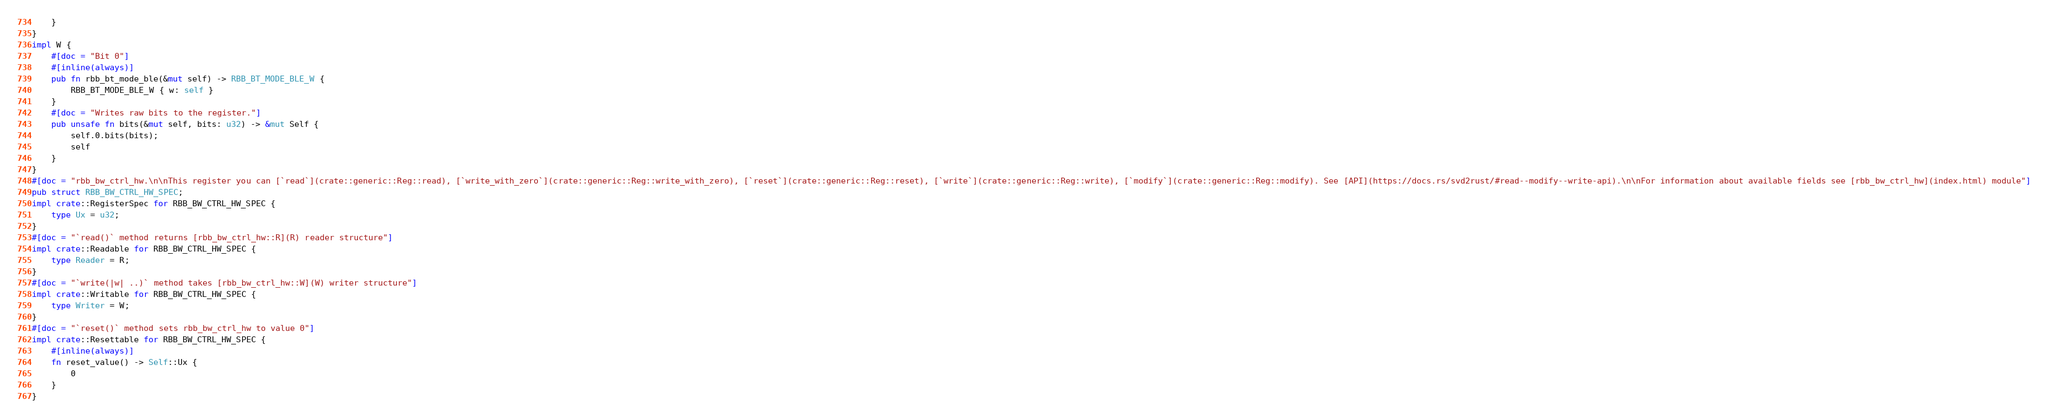<code> <loc_0><loc_0><loc_500><loc_500><_Rust_>    }
}
impl W {
    #[doc = "Bit 0"]
    #[inline(always)]
    pub fn rbb_bt_mode_ble(&mut self) -> RBB_BT_MODE_BLE_W {
        RBB_BT_MODE_BLE_W { w: self }
    }
    #[doc = "Writes raw bits to the register."]
    pub unsafe fn bits(&mut self, bits: u32) -> &mut Self {
        self.0.bits(bits);
        self
    }
}
#[doc = "rbb_bw_ctrl_hw.\n\nThis register you can [`read`](crate::generic::Reg::read), [`write_with_zero`](crate::generic::Reg::write_with_zero), [`reset`](crate::generic::Reg::reset), [`write`](crate::generic::Reg::write), [`modify`](crate::generic::Reg::modify). See [API](https://docs.rs/svd2rust/#read--modify--write-api).\n\nFor information about available fields see [rbb_bw_ctrl_hw](index.html) module"]
pub struct RBB_BW_CTRL_HW_SPEC;
impl crate::RegisterSpec for RBB_BW_CTRL_HW_SPEC {
    type Ux = u32;
}
#[doc = "`read()` method returns [rbb_bw_ctrl_hw::R](R) reader structure"]
impl crate::Readable for RBB_BW_CTRL_HW_SPEC {
    type Reader = R;
}
#[doc = "`write(|w| ..)` method takes [rbb_bw_ctrl_hw::W](W) writer structure"]
impl crate::Writable for RBB_BW_CTRL_HW_SPEC {
    type Writer = W;
}
#[doc = "`reset()` method sets rbb_bw_ctrl_hw to value 0"]
impl crate::Resettable for RBB_BW_CTRL_HW_SPEC {
    #[inline(always)]
    fn reset_value() -> Self::Ux {
        0
    }
}
</code> 